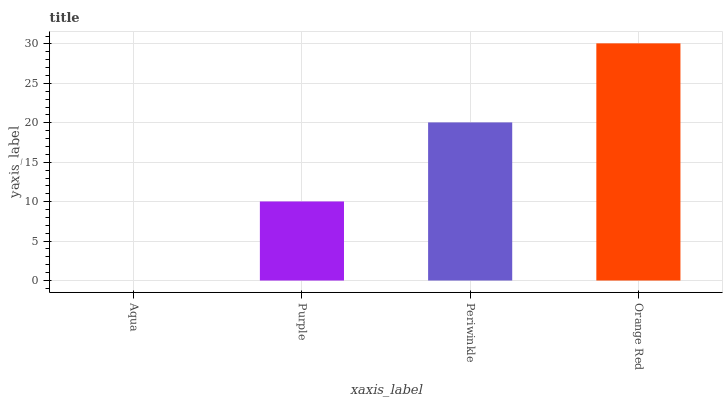Is Aqua the minimum?
Answer yes or no. Yes. Is Orange Red the maximum?
Answer yes or no. Yes. Is Purple the minimum?
Answer yes or no. No. Is Purple the maximum?
Answer yes or no. No. Is Purple greater than Aqua?
Answer yes or no. Yes. Is Aqua less than Purple?
Answer yes or no. Yes. Is Aqua greater than Purple?
Answer yes or no. No. Is Purple less than Aqua?
Answer yes or no. No. Is Periwinkle the high median?
Answer yes or no. Yes. Is Purple the low median?
Answer yes or no. Yes. Is Purple the high median?
Answer yes or no. No. Is Orange Red the low median?
Answer yes or no. No. 